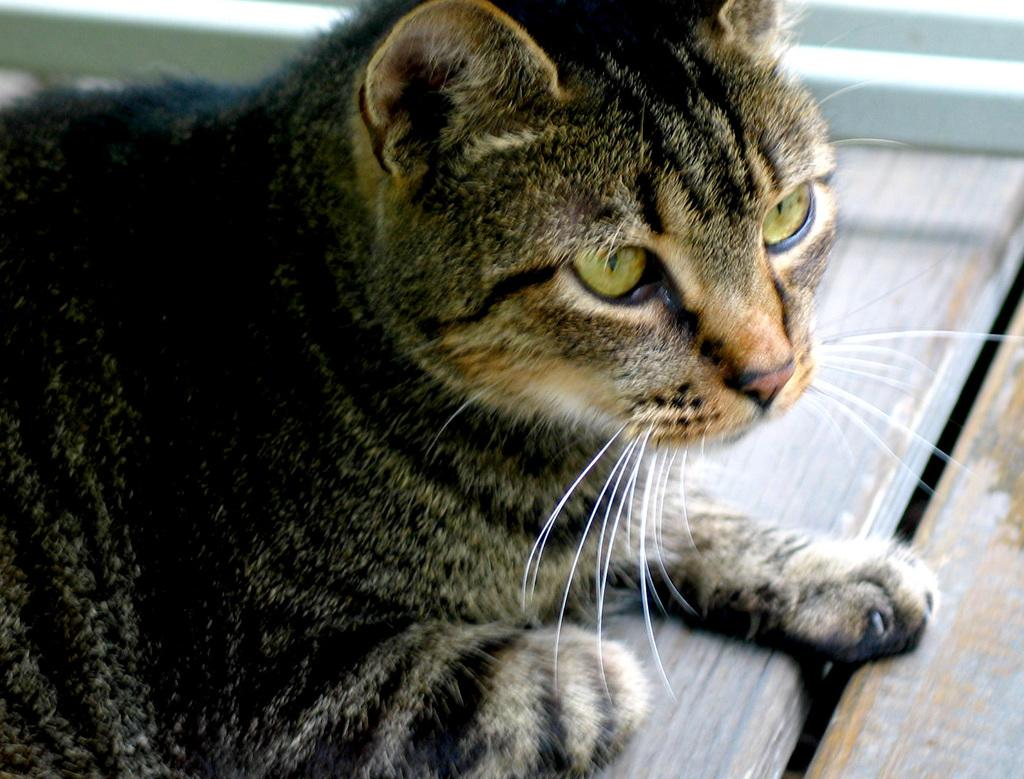What type of animal is present in the image? There is a cat in the image. Can you describe the cat's location in the image? The cat is on a surface in the image. How many cemeteries are visible in the image? There are no cemeteries visible in the image; it features a cat on a surface. What type of approval is required for the cat in the image? There is no approval required for the cat in the image, as it is a photograph and not a real-life situation. 